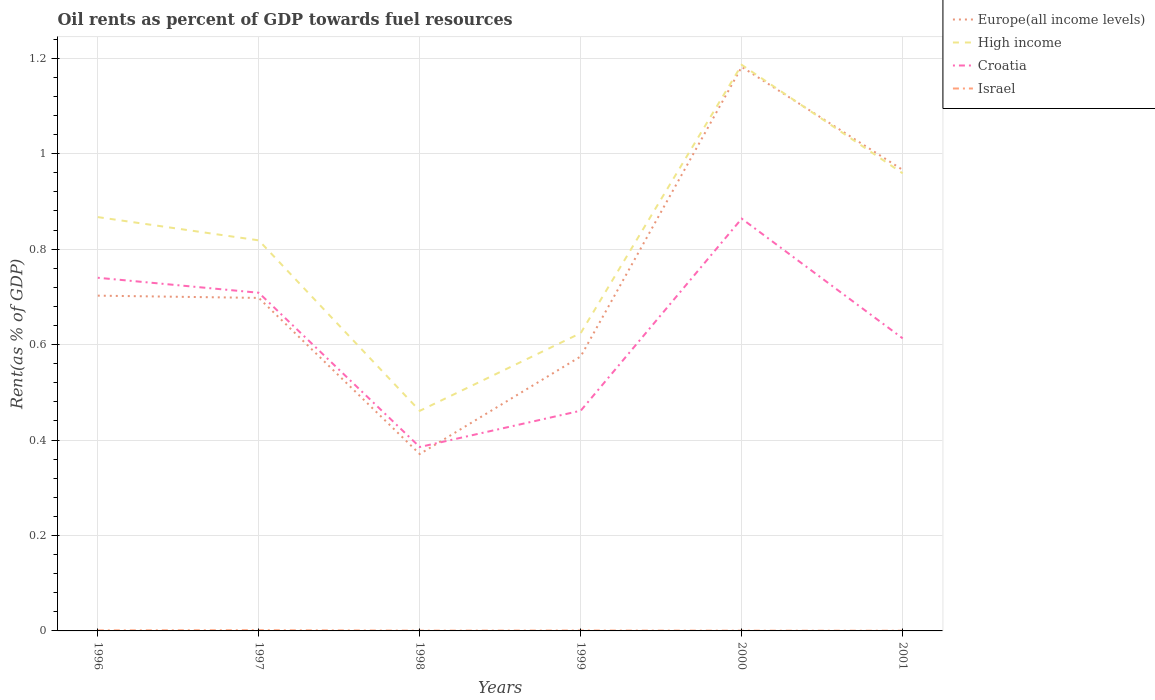How many different coloured lines are there?
Offer a terse response. 4. Across all years, what is the maximum oil rent in Croatia?
Ensure brevity in your answer.  0.39. What is the total oil rent in High income in the graph?
Ensure brevity in your answer.  0.24. What is the difference between the highest and the second highest oil rent in Europe(all income levels)?
Your answer should be compact. 0.81. Is the oil rent in High income strictly greater than the oil rent in Israel over the years?
Give a very brief answer. No. How many lines are there?
Your response must be concise. 4. How many years are there in the graph?
Your answer should be compact. 6. Where does the legend appear in the graph?
Offer a terse response. Top right. What is the title of the graph?
Make the answer very short. Oil rents as percent of GDP towards fuel resources. Does "Argentina" appear as one of the legend labels in the graph?
Your answer should be compact. No. What is the label or title of the X-axis?
Your answer should be compact. Years. What is the label or title of the Y-axis?
Make the answer very short. Rent(as % of GDP). What is the Rent(as % of GDP) in Europe(all income levels) in 1996?
Provide a succinct answer. 0.7. What is the Rent(as % of GDP) of High income in 1996?
Provide a short and direct response. 0.87. What is the Rent(as % of GDP) of Croatia in 1996?
Keep it short and to the point. 0.74. What is the Rent(as % of GDP) in Israel in 1996?
Offer a terse response. 0. What is the Rent(as % of GDP) in Europe(all income levels) in 1997?
Offer a very short reply. 0.7. What is the Rent(as % of GDP) of High income in 1997?
Your answer should be compact. 0.82. What is the Rent(as % of GDP) in Croatia in 1997?
Offer a terse response. 0.71. What is the Rent(as % of GDP) in Israel in 1997?
Your response must be concise. 0. What is the Rent(as % of GDP) in Europe(all income levels) in 1998?
Your answer should be compact. 0.37. What is the Rent(as % of GDP) of High income in 1998?
Your answer should be very brief. 0.46. What is the Rent(as % of GDP) of Croatia in 1998?
Your answer should be compact. 0.39. What is the Rent(as % of GDP) in Israel in 1998?
Offer a very short reply. 0. What is the Rent(as % of GDP) of Europe(all income levels) in 1999?
Give a very brief answer. 0.58. What is the Rent(as % of GDP) of High income in 1999?
Provide a succinct answer. 0.62. What is the Rent(as % of GDP) in Croatia in 1999?
Offer a very short reply. 0.46. What is the Rent(as % of GDP) of Israel in 1999?
Your response must be concise. 0. What is the Rent(as % of GDP) in Europe(all income levels) in 2000?
Ensure brevity in your answer.  1.18. What is the Rent(as % of GDP) of High income in 2000?
Make the answer very short. 1.19. What is the Rent(as % of GDP) of Croatia in 2000?
Keep it short and to the point. 0.86. What is the Rent(as % of GDP) in Israel in 2000?
Your answer should be very brief. 0. What is the Rent(as % of GDP) of Europe(all income levels) in 2001?
Your response must be concise. 0.97. What is the Rent(as % of GDP) of High income in 2001?
Provide a succinct answer. 0.96. What is the Rent(as % of GDP) in Croatia in 2001?
Keep it short and to the point. 0.61. What is the Rent(as % of GDP) of Israel in 2001?
Ensure brevity in your answer.  0. Across all years, what is the maximum Rent(as % of GDP) of Europe(all income levels)?
Your answer should be very brief. 1.18. Across all years, what is the maximum Rent(as % of GDP) in High income?
Offer a terse response. 1.19. Across all years, what is the maximum Rent(as % of GDP) of Croatia?
Ensure brevity in your answer.  0.86. Across all years, what is the maximum Rent(as % of GDP) of Israel?
Keep it short and to the point. 0. Across all years, what is the minimum Rent(as % of GDP) of Europe(all income levels)?
Keep it short and to the point. 0.37. Across all years, what is the minimum Rent(as % of GDP) in High income?
Offer a very short reply. 0.46. Across all years, what is the minimum Rent(as % of GDP) in Croatia?
Offer a very short reply. 0.39. Across all years, what is the minimum Rent(as % of GDP) in Israel?
Offer a very short reply. 0. What is the total Rent(as % of GDP) of Europe(all income levels) in the graph?
Make the answer very short. 4.49. What is the total Rent(as % of GDP) of High income in the graph?
Give a very brief answer. 4.92. What is the total Rent(as % of GDP) of Croatia in the graph?
Your answer should be compact. 3.77. What is the total Rent(as % of GDP) in Israel in the graph?
Your answer should be very brief. 0.01. What is the difference between the Rent(as % of GDP) in Europe(all income levels) in 1996 and that in 1997?
Your response must be concise. 0. What is the difference between the Rent(as % of GDP) of High income in 1996 and that in 1997?
Give a very brief answer. 0.05. What is the difference between the Rent(as % of GDP) in Croatia in 1996 and that in 1997?
Provide a short and direct response. 0.03. What is the difference between the Rent(as % of GDP) in Israel in 1996 and that in 1997?
Provide a succinct answer. -0. What is the difference between the Rent(as % of GDP) in Europe(all income levels) in 1996 and that in 1998?
Give a very brief answer. 0.33. What is the difference between the Rent(as % of GDP) in High income in 1996 and that in 1998?
Your answer should be very brief. 0.41. What is the difference between the Rent(as % of GDP) of Croatia in 1996 and that in 1998?
Make the answer very short. 0.35. What is the difference between the Rent(as % of GDP) in Israel in 1996 and that in 1998?
Offer a very short reply. 0. What is the difference between the Rent(as % of GDP) in Europe(all income levels) in 1996 and that in 1999?
Provide a short and direct response. 0.13. What is the difference between the Rent(as % of GDP) of High income in 1996 and that in 1999?
Keep it short and to the point. 0.24. What is the difference between the Rent(as % of GDP) of Croatia in 1996 and that in 1999?
Keep it short and to the point. 0.28. What is the difference between the Rent(as % of GDP) of Europe(all income levels) in 1996 and that in 2000?
Provide a short and direct response. -0.48. What is the difference between the Rent(as % of GDP) in High income in 1996 and that in 2000?
Your response must be concise. -0.32. What is the difference between the Rent(as % of GDP) in Croatia in 1996 and that in 2000?
Provide a short and direct response. -0.12. What is the difference between the Rent(as % of GDP) in Israel in 1996 and that in 2000?
Provide a short and direct response. 0. What is the difference between the Rent(as % of GDP) in Europe(all income levels) in 1996 and that in 2001?
Ensure brevity in your answer.  -0.26. What is the difference between the Rent(as % of GDP) of High income in 1996 and that in 2001?
Your answer should be compact. -0.09. What is the difference between the Rent(as % of GDP) of Croatia in 1996 and that in 2001?
Offer a very short reply. 0.13. What is the difference between the Rent(as % of GDP) in Israel in 1996 and that in 2001?
Keep it short and to the point. 0. What is the difference between the Rent(as % of GDP) of Europe(all income levels) in 1997 and that in 1998?
Your answer should be compact. 0.33. What is the difference between the Rent(as % of GDP) of High income in 1997 and that in 1998?
Make the answer very short. 0.36. What is the difference between the Rent(as % of GDP) of Croatia in 1997 and that in 1998?
Make the answer very short. 0.32. What is the difference between the Rent(as % of GDP) of Israel in 1997 and that in 1998?
Your answer should be very brief. 0. What is the difference between the Rent(as % of GDP) in Europe(all income levels) in 1997 and that in 1999?
Provide a succinct answer. 0.12. What is the difference between the Rent(as % of GDP) in High income in 1997 and that in 1999?
Keep it short and to the point. 0.19. What is the difference between the Rent(as % of GDP) in Croatia in 1997 and that in 1999?
Provide a short and direct response. 0.25. What is the difference between the Rent(as % of GDP) of Israel in 1997 and that in 1999?
Give a very brief answer. 0. What is the difference between the Rent(as % of GDP) in Europe(all income levels) in 1997 and that in 2000?
Provide a succinct answer. -0.48. What is the difference between the Rent(as % of GDP) of High income in 1997 and that in 2000?
Ensure brevity in your answer.  -0.37. What is the difference between the Rent(as % of GDP) of Croatia in 1997 and that in 2000?
Your answer should be compact. -0.16. What is the difference between the Rent(as % of GDP) of Israel in 1997 and that in 2000?
Give a very brief answer. 0. What is the difference between the Rent(as % of GDP) of Europe(all income levels) in 1997 and that in 2001?
Give a very brief answer. -0.27. What is the difference between the Rent(as % of GDP) in High income in 1997 and that in 2001?
Provide a succinct answer. -0.14. What is the difference between the Rent(as % of GDP) in Croatia in 1997 and that in 2001?
Your answer should be compact. 0.1. What is the difference between the Rent(as % of GDP) of Israel in 1997 and that in 2001?
Your answer should be compact. 0. What is the difference between the Rent(as % of GDP) in Europe(all income levels) in 1998 and that in 1999?
Your answer should be very brief. -0.2. What is the difference between the Rent(as % of GDP) of High income in 1998 and that in 1999?
Your answer should be very brief. -0.16. What is the difference between the Rent(as % of GDP) of Croatia in 1998 and that in 1999?
Provide a short and direct response. -0.08. What is the difference between the Rent(as % of GDP) in Israel in 1998 and that in 1999?
Keep it short and to the point. -0. What is the difference between the Rent(as % of GDP) of Europe(all income levels) in 1998 and that in 2000?
Ensure brevity in your answer.  -0.81. What is the difference between the Rent(as % of GDP) of High income in 1998 and that in 2000?
Provide a succinct answer. -0.72. What is the difference between the Rent(as % of GDP) of Croatia in 1998 and that in 2000?
Keep it short and to the point. -0.48. What is the difference between the Rent(as % of GDP) of Israel in 1998 and that in 2000?
Your answer should be very brief. 0. What is the difference between the Rent(as % of GDP) in Europe(all income levels) in 1998 and that in 2001?
Provide a short and direct response. -0.6. What is the difference between the Rent(as % of GDP) in High income in 1998 and that in 2001?
Your response must be concise. -0.5. What is the difference between the Rent(as % of GDP) of Croatia in 1998 and that in 2001?
Provide a succinct answer. -0.23. What is the difference between the Rent(as % of GDP) of Europe(all income levels) in 1999 and that in 2000?
Provide a succinct answer. -0.61. What is the difference between the Rent(as % of GDP) in High income in 1999 and that in 2000?
Make the answer very short. -0.56. What is the difference between the Rent(as % of GDP) in Croatia in 1999 and that in 2000?
Provide a short and direct response. -0.4. What is the difference between the Rent(as % of GDP) of Israel in 1999 and that in 2000?
Your response must be concise. 0. What is the difference between the Rent(as % of GDP) in Europe(all income levels) in 1999 and that in 2001?
Keep it short and to the point. -0.39. What is the difference between the Rent(as % of GDP) of High income in 1999 and that in 2001?
Provide a succinct answer. -0.33. What is the difference between the Rent(as % of GDP) in Croatia in 1999 and that in 2001?
Your response must be concise. -0.15. What is the difference between the Rent(as % of GDP) in Israel in 1999 and that in 2001?
Provide a short and direct response. 0. What is the difference between the Rent(as % of GDP) in Europe(all income levels) in 2000 and that in 2001?
Provide a short and direct response. 0.22. What is the difference between the Rent(as % of GDP) of High income in 2000 and that in 2001?
Make the answer very short. 0.23. What is the difference between the Rent(as % of GDP) of Croatia in 2000 and that in 2001?
Keep it short and to the point. 0.25. What is the difference between the Rent(as % of GDP) of Europe(all income levels) in 1996 and the Rent(as % of GDP) of High income in 1997?
Your response must be concise. -0.12. What is the difference between the Rent(as % of GDP) in Europe(all income levels) in 1996 and the Rent(as % of GDP) in Croatia in 1997?
Make the answer very short. -0.01. What is the difference between the Rent(as % of GDP) of Europe(all income levels) in 1996 and the Rent(as % of GDP) of Israel in 1997?
Your answer should be compact. 0.7. What is the difference between the Rent(as % of GDP) of High income in 1996 and the Rent(as % of GDP) of Croatia in 1997?
Make the answer very short. 0.16. What is the difference between the Rent(as % of GDP) of High income in 1996 and the Rent(as % of GDP) of Israel in 1997?
Offer a very short reply. 0.87. What is the difference between the Rent(as % of GDP) in Croatia in 1996 and the Rent(as % of GDP) in Israel in 1997?
Provide a succinct answer. 0.74. What is the difference between the Rent(as % of GDP) of Europe(all income levels) in 1996 and the Rent(as % of GDP) of High income in 1998?
Give a very brief answer. 0.24. What is the difference between the Rent(as % of GDP) of Europe(all income levels) in 1996 and the Rent(as % of GDP) of Croatia in 1998?
Provide a short and direct response. 0.32. What is the difference between the Rent(as % of GDP) in Europe(all income levels) in 1996 and the Rent(as % of GDP) in Israel in 1998?
Your answer should be compact. 0.7. What is the difference between the Rent(as % of GDP) of High income in 1996 and the Rent(as % of GDP) of Croatia in 1998?
Keep it short and to the point. 0.48. What is the difference between the Rent(as % of GDP) of High income in 1996 and the Rent(as % of GDP) of Israel in 1998?
Your answer should be compact. 0.87. What is the difference between the Rent(as % of GDP) in Croatia in 1996 and the Rent(as % of GDP) in Israel in 1998?
Ensure brevity in your answer.  0.74. What is the difference between the Rent(as % of GDP) of Europe(all income levels) in 1996 and the Rent(as % of GDP) of High income in 1999?
Offer a very short reply. 0.08. What is the difference between the Rent(as % of GDP) of Europe(all income levels) in 1996 and the Rent(as % of GDP) of Croatia in 1999?
Provide a succinct answer. 0.24. What is the difference between the Rent(as % of GDP) in Europe(all income levels) in 1996 and the Rent(as % of GDP) in Israel in 1999?
Offer a terse response. 0.7. What is the difference between the Rent(as % of GDP) in High income in 1996 and the Rent(as % of GDP) in Croatia in 1999?
Your answer should be very brief. 0.41. What is the difference between the Rent(as % of GDP) of High income in 1996 and the Rent(as % of GDP) of Israel in 1999?
Keep it short and to the point. 0.87. What is the difference between the Rent(as % of GDP) of Croatia in 1996 and the Rent(as % of GDP) of Israel in 1999?
Provide a short and direct response. 0.74. What is the difference between the Rent(as % of GDP) in Europe(all income levels) in 1996 and the Rent(as % of GDP) in High income in 2000?
Give a very brief answer. -0.48. What is the difference between the Rent(as % of GDP) in Europe(all income levels) in 1996 and the Rent(as % of GDP) in Croatia in 2000?
Give a very brief answer. -0.16. What is the difference between the Rent(as % of GDP) in Europe(all income levels) in 1996 and the Rent(as % of GDP) in Israel in 2000?
Your answer should be very brief. 0.7. What is the difference between the Rent(as % of GDP) in High income in 1996 and the Rent(as % of GDP) in Croatia in 2000?
Keep it short and to the point. 0. What is the difference between the Rent(as % of GDP) in High income in 1996 and the Rent(as % of GDP) in Israel in 2000?
Provide a succinct answer. 0.87. What is the difference between the Rent(as % of GDP) of Croatia in 1996 and the Rent(as % of GDP) of Israel in 2000?
Offer a terse response. 0.74. What is the difference between the Rent(as % of GDP) of Europe(all income levels) in 1996 and the Rent(as % of GDP) of High income in 2001?
Give a very brief answer. -0.26. What is the difference between the Rent(as % of GDP) of Europe(all income levels) in 1996 and the Rent(as % of GDP) of Croatia in 2001?
Keep it short and to the point. 0.09. What is the difference between the Rent(as % of GDP) in Europe(all income levels) in 1996 and the Rent(as % of GDP) in Israel in 2001?
Make the answer very short. 0.7. What is the difference between the Rent(as % of GDP) in High income in 1996 and the Rent(as % of GDP) in Croatia in 2001?
Your response must be concise. 0.25. What is the difference between the Rent(as % of GDP) in High income in 1996 and the Rent(as % of GDP) in Israel in 2001?
Provide a short and direct response. 0.87. What is the difference between the Rent(as % of GDP) of Croatia in 1996 and the Rent(as % of GDP) of Israel in 2001?
Offer a terse response. 0.74. What is the difference between the Rent(as % of GDP) in Europe(all income levels) in 1997 and the Rent(as % of GDP) in High income in 1998?
Offer a terse response. 0.24. What is the difference between the Rent(as % of GDP) in Europe(all income levels) in 1997 and the Rent(as % of GDP) in Croatia in 1998?
Provide a succinct answer. 0.31. What is the difference between the Rent(as % of GDP) of Europe(all income levels) in 1997 and the Rent(as % of GDP) of Israel in 1998?
Your answer should be very brief. 0.7. What is the difference between the Rent(as % of GDP) of High income in 1997 and the Rent(as % of GDP) of Croatia in 1998?
Offer a very short reply. 0.43. What is the difference between the Rent(as % of GDP) in High income in 1997 and the Rent(as % of GDP) in Israel in 1998?
Provide a short and direct response. 0.82. What is the difference between the Rent(as % of GDP) in Croatia in 1997 and the Rent(as % of GDP) in Israel in 1998?
Offer a very short reply. 0.71. What is the difference between the Rent(as % of GDP) in Europe(all income levels) in 1997 and the Rent(as % of GDP) in High income in 1999?
Provide a short and direct response. 0.07. What is the difference between the Rent(as % of GDP) of Europe(all income levels) in 1997 and the Rent(as % of GDP) of Croatia in 1999?
Your answer should be compact. 0.24. What is the difference between the Rent(as % of GDP) in Europe(all income levels) in 1997 and the Rent(as % of GDP) in Israel in 1999?
Your answer should be compact. 0.7. What is the difference between the Rent(as % of GDP) of High income in 1997 and the Rent(as % of GDP) of Croatia in 1999?
Your response must be concise. 0.36. What is the difference between the Rent(as % of GDP) of High income in 1997 and the Rent(as % of GDP) of Israel in 1999?
Your answer should be very brief. 0.82. What is the difference between the Rent(as % of GDP) of Croatia in 1997 and the Rent(as % of GDP) of Israel in 1999?
Your answer should be compact. 0.71. What is the difference between the Rent(as % of GDP) in Europe(all income levels) in 1997 and the Rent(as % of GDP) in High income in 2000?
Your response must be concise. -0.49. What is the difference between the Rent(as % of GDP) of Europe(all income levels) in 1997 and the Rent(as % of GDP) of Croatia in 2000?
Your response must be concise. -0.17. What is the difference between the Rent(as % of GDP) of Europe(all income levels) in 1997 and the Rent(as % of GDP) of Israel in 2000?
Give a very brief answer. 0.7. What is the difference between the Rent(as % of GDP) in High income in 1997 and the Rent(as % of GDP) in Croatia in 2000?
Provide a short and direct response. -0.05. What is the difference between the Rent(as % of GDP) of High income in 1997 and the Rent(as % of GDP) of Israel in 2000?
Your answer should be very brief. 0.82. What is the difference between the Rent(as % of GDP) of Croatia in 1997 and the Rent(as % of GDP) of Israel in 2000?
Provide a succinct answer. 0.71. What is the difference between the Rent(as % of GDP) of Europe(all income levels) in 1997 and the Rent(as % of GDP) of High income in 2001?
Provide a succinct answer. -0.26. What is the difference between the Rent(as % of GDP) of Europe(all income levels) in 1997 and the Rent(as % of GDP) of Croatia in 2001?
Your response must be concise. 0.08. What is the difference between the Rent(as % of GDP) of Europe(all income levels) in 1997 and the Rent(as % of GDP) of Israel in 2001?
Your answer should be very brief. 0.7. What is the difference between the Rent(as % of GDP) in High income in 1997 and the Rent(as % of GDP) in Croatia in 2001?
Provide a succinct answer. 0.21. What is the difference between the Rent(as % of GDP) of High income in 1997 and the Rent(as % of GDP) of Israel in 2001?
Your answer should be very brief. 0.82. What is the difference between the Rent(as % of GDP) of Croatia in 1997 and the Rent(as % of GDP) of Israel in 2001?
Your answer should be very brief. 0.71. What is the difference between the Rent(as % of GDP) in Europe(all income levels) in 1998 and the Rent(as % of GDP) in High income in 1999?
Your answer should be compact. -0.25. What is the difference between the Rent(as % of GDP) in Europe(all income levels) in 1998 and the Rent(as % of GDP) in Croatia in 1999?
Your answer should be very brief. -0.09. What is the difference between the Rent(as % of GDP) in Europe(all income levels) in 1998 and the Rent(as % of GDP) in Israel in 1999?
Offer a terse response. 0.37. What is the difference between the Rent(as % of GDP) in High income in 1998 and the Rent(as % of GDP) in Croatia in 1999?
Offer a very short reply. -0. What is the difference between the Rent(as % of GDP) of High income in 1998 and the Rent(as % of GDP) of Israel in 1999?
Offer a terse response. 0.46. What is the difference between the Rent(as % of GDP) in Croatia in 1998 and the Rent(as % of GDP) in Israel in 1999?
Your answer should be very brief. 0.38. What is the difference between the Rent(as % of GDP) of Europe(all income levels) in 1998 and the Rent(as % of GDP) of High income in 2000?
Keep it short and to the point. -0.82. What is the difference between the Rent(as % of GDP) of Europe(all income levels) in 1998 and the Rent(as % of GDP) of Croatia in 2000?
Your answer should be very brief. -0.49. What is the difference between the Rent(as % of GDP) of Europe(all income levels) in 1998 and the Rent(as % of GDP) of Israel in 2000?
Keep it short and to the point. 0.37. What is the difference between the Rent(as % of GDP) of High income in 1998 and the Rent(as % of GDP) of Croatia in 2000?
Provide a short and direct response. -0.4. What is the difference between the Rent(as % of GDP) of High income in 1998 and the Rent(as % of GDP) of Israel in 2000?
Offer a very short reply. 0.46. What is the difference between the Rent(as % of GDP) of Croatia in 1998 and the Rent(as % of GDP) of Israel in 2000?
Provide a short and direct response. 0.38. What is the difference between the Rent(as % of GDP) of Europe(all income levels) in 1998 and the Rent(as % of GDP) of High income in 2001?
Offer a terse response. -0.59. What is the difference between the Rent(as % of GDP) of Europe(all income levels) in 1998 and the Rent(as % of GDP) of Croatia in 2001?
Offer a terse response. -0.24. What is the difference between the Rent(as % of GDP) in Europe(all income levels) in 1998 and the Rent(as % of GDP) in Israel in 2001?
Ensure brevity in your answer.  0.37. What is the difference between the Rent(as % of GDP) in High income in 1998 and the Rent(as % of GDP) in Croatia in 2001?
Keep it short and to the point. -0.15. What is the difference between the Rent(as % of GDP) in High income in 1998 and the Rent(as % of GDP) in Israel in 2001?
Make the answer very short. 0.46. What is the difference between the Rent(as % of GDP) of Croatia in 1998 and the Rent(as % of GDP) of Israel in 2001?
Give a very brief answer. 0.38. What is the difference between the Rent(as % of GDP) in Europe(all income levels) in 1999 and the Rent(as % of GDP) in High income in 2000?
Make the answer very short. -0.61. What is the difference between the Rent(as % of GDP) of Europe(all income levels) in 1999 and the Rent(as % of GDP) of Croatia in 2000?
Your response must be concise. -0.29. What is the difference between the Rent(as % of GDP) in Europe(all income levels) in 1999 and the Rent(as % of GDP) in Israel in 2000?
Ensure brevity in your answer.  0.57. What is the difference between the Rent(as % of GDP) in High income in 1999 and the Rent(as % of GDP) in Croatia in 2000?
Ensure brevity in your answer.  -0.24. What is the difference between the Rent(as % of GDP) in High income in 1999 and the Rent(as % of GDP) in Israel in 2000?
Ensure brevity in your answer.  0.62. What is the difference between the Rent(as % of GDP) of Croatia in 1999 and the Rent(as % of GDP) of Israel in 2000?
Provide a short and direct response. 0.46. What is the difference between the Rent(as % of GDP) of Europe(all income levels) in 1999 and the Rent(as % of GDP) of High income in 2001?
Provide a succinct answer. -0.38. What is the difference between the Rent(as % of GDP) in Europe(all income levels) in 1999 and the Rent(as % of GDP) in Croatia in 2001?
Make the answer very short. -0.04. What is the difference between the Rent(as % of GDP) in Europe(all income levels) in 1999 and the Rent(as % of GDP) in Israel in 2001?
Ensure brevity in your answer.  0.57. What is the difference between the Rent(as % of GDP) of High income in 1999 and the Rent(as % of GDP) of Croatia in 2001?
Provide a succinct answer. 0.01. What is the difference between the Rent(as % of GDP) of High income in 1999 and the Rent(as % of GDP) of Israel in 2001?
Provide a short and direct response. 0.62. What is the difference between the Rent(as % of GDP) in Croatia in 1999 and the Rent(as % of GDP) in Israel in 2001?
Ensure brevity in your answer.  0.46. What is the difference between the Rent(as % of GDP) of Europe(all income levels) in 2000 and the Rent(as % of GDP) of High income in 2001?
Offer a terse response. 0.22. What is the difference between the Rent(as % of GDP) of Europe(all income levels) in 2000 and the Rent(as % of GDP) of Croatia in 2001?
Your response must be concise. 0.57. What is the difference between the Rent(as % of GDP) of Europe(all income levels) in 2000 and the Rent(as % of GDP) of Israel in 2001?
Provide a short and direct response. 1.18. What is the difference between the Rent(as % of GDP) in High income in 2000 and the Rent(as % of GDP) in Croatia in 2001?
Your response must be concise. 0.57. What is the difference between the Rent(as % of GDP) in High income in 2000 and the Rent(as % of GDP) in Israel in 2001?
Offer a very short reply. 1.19. What is the difference between the Rent(as % of GDP) in Croatia in 2000 and the Rent(as % of GDP) in Israel in 2001?
Give a very brief answer. 0.86. What is the average Rent(as % of GDP) in Europe(all income levels) per year?
Give a very brief answer. 0.75. What is the average Rent(as % of GDP) in High income per year?
Make the answer very short. 0.82. What is the average Rent(as % of GDP) in Croatia per year?
Make the answer very short. 0.63. What is the average Rent(as % of GDP) of Israel per year?
Ensure brevity in your answer.  0. In the year 1996, what is the difference between the Rent(as % of GDP) in Europe(all income levels) and Rent(as % of GDP) in High income?
Offer a very short reply. -0.16. In the year 1996, what is the difference between the Rent(as % of GDP) in Europe(all income levels) and Rent(as % of GDP) in Croatia?
Keep it short and to the point. -0.04. In the year 1996, what is the difference between the Rent(as % of GDP) in Europe(all income levels) and Rent(as % of GDP) in Israel?
Provide a short and direct response. 0.7. In the year 1996, what is the difference between the Rent(as % of GDP) in High income and Rent(as % of GDP) in Croatia?
Keep it short and to the point. 0.13. In the year 1996, what is the difference between the Rent(as % of GDP) of High income and Rent(as % of GDP) of Israel?
Offer a very short reply. 0.87. In the year 1996, what is the difference between the Rent(as % of GDP) in Croatia and Rent(as % of GDP) in Israel?
Keep it short and to the point. 0.74. In the year 1997, what is the difference between the Rent(as % of GDP) in Europe(all income levels) and Rent(as % of GDP) in High income?
Offer a terse response. -0.12. In the year 1997, what is the difference between the Rent(as % of GDP) in Europe(all income levels) and Rent(as % of GDP) in Croatia?
Provide a succinct answer. -0.01. In the year 1997, what is the difference between the Rent(as % of GDP) in Europe(all income levels) and Rent(as % of GDP) in Israel?
Your answer should be compact. 0.7. In the year 1997, what is the difference between the Rent(as % of GDP) of High income and Rent(as % of GDP) of Croatia?
Your answer should be very brief. 0.11. In the year 1997, what is the difference between the Rent(as % of GDP) in High income and Rent(as % of GDP) in Israel?
Your answer should be compact. 0.82. In the year 1997, what is the difference between the Rent(as % of GDP) of Croatia and Rent(as % of GDP) of Israel?
Ensure brevity in your answer.  0.71. In the year 1998, what is the difference between the Rent(as % of GDP) of Europe(all income levels) and Rent(as % of GDP) of High income?
Make the answer very short. -0.09. In the year 1998, what is the difference between the Rent(as % of GDP) in Europe(all income levels) and Rent(as % of GDP) in Croatia?
Your response must be concise. -0.01. In the year 1998, what is the difference between the Rent(as % of GDP) of Europe(all income levels) and Rent(as % of GDP) of Israel?
Your response must be concise. 0.37. In the year 1998, what is the difference between the Rent(as % of GDP) in High income and Rent(as % of GDP) in Croatia?
Provide a succinct answer. 0.08. In the year 1998, what is the difference between the Rent(as % of GDP) in High income and Rent(as % of GDP) in Israel?
Your response must be concise. 0.46. In the year 1998, what is the difference between the Rent(as % of GDP) in Croatia and Rent(as % of GDP) in Israel?
Offer a terse response. 0.38. In the year 1999, what is the difference between the Rent(as % of GDP) in Europe(all income levels) and Rent(as % of GDP) in High income?
Keep it short and to the point. -0.05. In the year 1999, what is the difference between the Rent(as % of GDP) of Europe(all income levels) and Rent(as % of GDP) of Croatia?
Your answer should be very brief. 0.11. In the year 1999, what is the difference between the Rent(as % of GDP) in Europe(all income levels) and Rent(as % of GDP) in Israel?
Provide a succinct answer. 0.57. In the year 1999, what is the difference between the Rent(as % of GDP) in High income and Rent(as % of GDP) in Croatia?
Provide a short and direct response. 0.16. In the year 1999, what is the difference between the Rent(as % of GDP) of High income and Rent(as % of GDP) of Israel?
Your response must be concise. 0.62. In the year 1999, what is the difference between the Rent(as % of GDP) of Croatia and Rent(as % of GDP) of Israel?
Make the answer very short. 0.46. In the year 2000, what is the difference between the Rent(as % of GDP) of Europe(all income levels) and Rent(as % of GDP) of High income?
Provide a short and direct response. -0. In the year 2000, what is the difference between the Rent(as % of GDP) of Europe(all income levels) and Rent(as % of GDP) of Croatia?
Give a very brief answer. 0.32. In the year 2000, what is the difference between the Rent(as % of GDP) of Europe(all income levels) and Rent(as % of GDP) of Israel?
Your response must be concise. 1.18. In the year 2000, what is the difference between the Rent(as % of GDP) in High income and Rent(as % of GDP) in Croatia?
Provide a short and direct response. 0.32. In the year 2000, what is the difference between the Rent(as % of GDP) of High income and Rent(as % of GDP) of Israel?
Your answer should be compact. 1.19. In the year 2000, what is the difference between the Rent(as % of GDP) in Croatia and Rent(as % of GDP) in Israel?
Give a very brief answer. 0.86. In the year 2001, what is the difference between the Rent(as % of GDP) of Europe(all income levels) and Rent(as % of GDP) of High income?
Give a very brief answer. 0.01. In the year 2001, what is the difference between the Rent(as % of GDP) in Europe(all income levels) and Rent(as % of GDP) in Croatia?
Provide a succinct answer. 0.35. In the year 2001, what is the difference between the Rent(as % of GDP) in Europe(all income levels) and Rent(as % of GDP) in Israel?
Offer a very short reply. 0.97. In the year 2001, what is the difference between the Rent(as % of GDP) of High income and Rent(as % of GDP) of Croatia?
Make the answer very short. 0.35. In the year 2001, what is the difference between the Rent(as % of GDP) of High income and Rent(as % of GDP) of Israel?
Provide a short and direct response. 0.96. In the year 2001, what is the difference between the Rent(as % of GDP) in Croatia and Rent(as % of GDP) in Israel?
Provide a short and direct response. 0.61. What is the ratio of the Rent(as % of GDP) of Europe(all income levels) in 1996 to that in 1997?
Make the answer very short. 1.01. What is the ratio of the Rent(as % of GDP) of High income in 1996 to that in 1997?
Give a very brief answer. 1.06. What is the ratio of the Rent(as % of GDP) in Croatia in 1996 to that in 1997?
Provide a short and direct response. 1.04. What is the ratio of the Rent(as % of GDP) in Israel in 1996 to that in 1997?
Offer a very short reply. 0.75. What is the ratio of the Rent(as % of GDP) in Europe(all income levels) in 1996 to that in 1998?
Your response must be concise. 1.9. What is the ratio of the Rent(as % of GDP) in High income in 1996 to that in 1998?
Provide a short and direct response. 1.88. What is the ratio of the Rent(as % of GDP) in Croatia in 1996 to that in 1998?
Make the answer very short. 1.92. What is the ratio of the Rent(as % of GDP) of Israel in 1996 to that in 1998?
Offer a terse response. 1.92. What is the ratio of the Rent(as % of GDP) of Europe(all income levels) in 1996 to that in 1999?
Provide a succinct answer. 1.22. What is the ratio of the Rent(as % of GDP) in High income in 1996 to that in 1999?
Offer a terse response. 1.39. What is the ratio of the Rent(as % of GDP) in Croatia in 1996 to that in 1999?
Offer a very short reply. 1.6. What is the ratio of the Rent(as % of GDP) of Israel in 1996 to that in 1999?
Offer a very short reply. 1.33. What is the ratio of the Rent(as % of GDP) in Europe(all income levels) in 1996 to that in 2000?
Ensure brevity in your answer.  0.59. What is the ratio of the Rent(as % of GDP) in High income in 1996 to that in 2000?
Your answer should be very brief. 0.73. What is the ratio of the Rent(as % of GDP) in Croatia in 1996 to that in 2000?
Keep it short and to the point. 0.86. What is the ratio of the Rent(as % of GDP) in Israel in 1996 to that in 2000?
Ensure brevity in your answer.  2.14. What is the ratio of the Rent(as % of GDP) in Europe(all income levels) in 1996 to that in 2001?
Keep it short and to the point. 0.73. What is the ratio of the Rent(as % of GDP) of High income in 1996 to that in 2001?
Your response must be concise. 0.9. What is the ratio of the Rent(as % of GDP) of Croatia in 1996 to that in 2001?
Your answer should be very brief. 1.21. What is the ratio of the Rent(as % of GDP) of Israel in 1996 to that in 2001?
Provide a succinct answer. 2.56. What is the ratio of the Rent(as % of GDP) in Europe(all income levels) in 1997 to that in 1998?
Keep it short and to the point. 1.88. What is the ratio of the Rent(as % of GDP) in High income in 1997 to that in 1998?
Make the answer very short. 1.77. What is the ratio of the Rent(as % of GDP) in Croatia in 1997 to that in 1998?
Provide a short and direct response. 1.84. What is the ratio of the Rent(as % of GDP) in Israel in 1997 to that in 1998?
Ensure brevity in your answer.  2.57. What is the ratio of the Rent(as % of GDP) of Europe(all income levels) in 1997 to that in 1999?
Ensure brevity in your answer.  1.21. What is the ratio of the Rent(as % of GDP) of High income in 1997 to that in 1999?
Your response must be concise. 1.31. What is the ratio of the Rent(as % of GDP) of Croatia in 1997 to that in 1999?
Make the answer very short. 1.54. What is the ratio of the Rent(as % of GDP) in Israel in 1997 to that in 1999?
Keep it short and to the point. 1.78. What is the ratio of the Rent(as % of GDP) in Europe(all income levels) in 1997 to that in 2000?
Your answer should be very brief. 0.59. What is the ratio of the Rent(as % of GDP) in High income in 1997 to that in 2000?
Your response must be concise. 0.69. What is the ratio of the Rent(as % of GDP) of Croatia in 1997 to that in 2000?
Ensure brevity in your answer.  0.82. What is the ratio of the Rent(as % of GDP) of Israel in 1997 to that in 2000?
Your response must be concise. 2.86. What is the ratio of the Rent(as % of GDP) of Europe(all income levels) in 1997 to that in 2001?
Offer a terse response. 0.72. What is the ratio of the Rent(as % of GDP) in High income in 1997 to that in 2001?
Provide a short and direct response. 0.85. What is the ratio of the Rent(as % of GDP) in Croatia in 1997 to that in 2001?
Give a very brief answer. 1.16. What is the ratio of the Rent(as % of GDP) of Israel in 1997 to that in 2001?
Make the answer very short. 3.43. What is the ratio of the Rent(as % of GDP) in Europe(all income levels) in 1998 to that in 1999?
Keep it short and to the point. 0.64. What is the ratio of the Rent(as % of GDP) of High income in 1998 to that in 1999?
Give a very brief answer. 0.74. What is the ratio of the Rent(as % of GDP) in Croatia in 1998 to that in 1999?
Your response must be concise. 0.84. What is the ratio of the Rent(as % of GDP) of Israel in 1998 to that in 1999?
Offer a terse response. 0.69. What is the ratio of the Rent(as % of GDP) in Europe(all income levels) in 1998 to that in 2000?
Provide a succinct answer. 0.31. What is the ratio of the Rent(as % of GDP) in High income in 1998 to that in 2000?
Provide a short and direct response. 0.39. What is the ratio of the Rent(as % of GDP) in Croatia in 1998 to that in 2000?
Offer a terse response. 0.45. What is the ratio of the Rent(as % of GDP) of Israel in 1998 to that in 2000?
Offer a terse response. 1.11. What is the ratio of the Rent(as % of GDP) in Europe(all income levels) in 1998 to that in 2001?
Your answer should be compact. 0.38. What is the ratio of the Rent(as % of GDP) in High income in 1998 to that in 2001?
Keep it short and to the point. 0.48. What is the ratio of the Rent(as % of GDP) of Croatia in 1998 to that in 2001?
Provide a succinct answer. 0.63. What is the ratio of the Rent(as % of GDP) in Israel in 1998 to that in 2001?
Offer a very short reply. 1.34. What is the ratio of the Rent(as % of GDP) in Europe(all income levels) in 1999 to that in 2000?
Make the answer very short. 0.49. What is the ratio of the Rent(as % of GDP) in High income in 1999 to that in 2000?
Offer a terse response. 0.53. What is the ratio of the Rent(as % of GDP) of Croatia in 1999 to that in 2000?
Give a very brief answer. 0.53. What is the ratio of the Rent(as % of GDP) of Israel in 1999 to that in 2000?
Provide a short and direct response. 1.6. What is the ratio of the Rent(as % of GDP) in Europe(all income levels) in 1999 to that in 2001?
Your answer should be very brief. 0.6. What is the ratio of the Rent(as % of GDP) of High income in 1999 to that in 2001?
Give a very brief answer. 0.65. What is the ratio of the Rent(as % of GDP) of Croatia in 1999 to that in 2001?
Make the answer very short. 0.75. What is the ratio of the Rent(as % of GDP) in Israel in 1999 to that in 2001?
Ensure brevity in your answer.  1.92. What is the ratio of the Rent(as % of GDP) in Europe(all income levels) in 2000 to that in 2001?
Your response must be concise. 1.22. What is the ratio of the Rent(as % of GDP) of High income in 2000 to that in 2001?
Give a very brief answer. 1.24. What is the ratio of the Rent(as % of GDP) of Croatia in 2000 to that in 2001?
Ensure brevity in your answer.  1.41. What is the ratio of the Rent(as % of GDP) of Israel in 2000 to that in 2001?
Make the answer very short. 1.2. What is the difference between the highest and the second highest Rent(as % of GDP) in Europe(all income levels)?
Provide a short and direct response. 0.22. What is the difference between the highest and the second highest Rent(as % of GDP) of High income?
Keep it short and to the point. 0.23. What is the difference between the highest and the second highest Rent(as % of GDP) of Croatia?
Give a very brief answer. 0.12. What is the difference between the highest and the second highest Rent(as % of GDP) of Israel?
Your answer should be compact. 0. What is the difference between the highest and the lowest Rent(as % of GDP) in Europe(all income levels)?
Make the answer very short. 0.81. What is the difference between the highest and the lowest Rent(as % of GDP) of High income?
Keep it short and to the point. 0.72. What is the difference between the highest and the lowest Rent(as % of GDP) in Croatia?
Offer a very short reply. 0.48. What is the difference between the highest and the lowest Rent(as % of GDP) in Israel?
Offer a terse response. 0. 